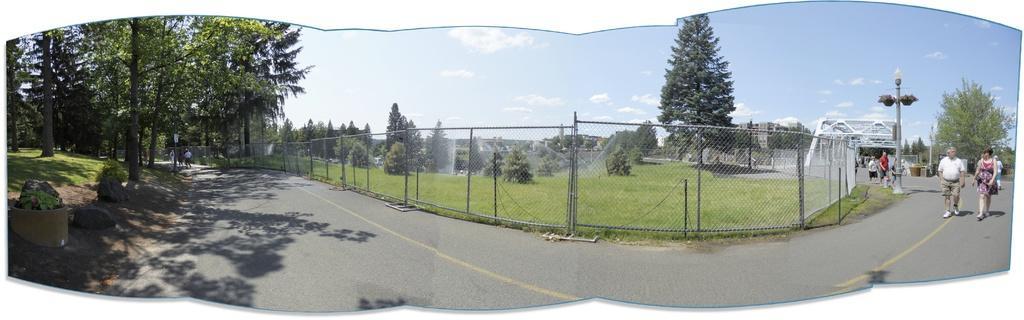Could you give a brief overview of what you see in this image? In this image there is a fence and behind the fence there are trees, there is grass on the ground, there are buildings. On the right side there are persons walking, there are trees and there is a pole. On the left side there are trees, plants and there is grass on the ground and there are persons visible and the sky is cloudy and in the front there is the road. 